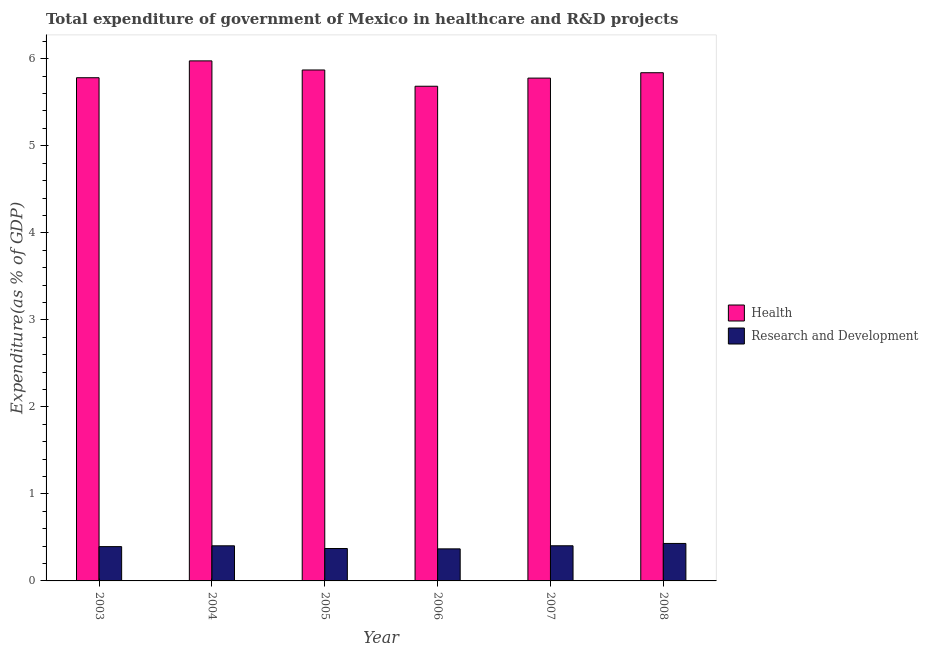How many different coloured bars are there?
Ensure brevity in your answer.  2. How many groups of bars are there?
Give a very brief answer. 6. Are the number of bars per tick equal to the number of legend labels?
Offer a very short reply. Yes. How many bars are there on the 5th tick from the left?
Provide a short and direct response. 2. How many bars are there on the 2nd tick from the right?
Provide a short and direct response. 2. What is the label of the 5th group of bars from the left?
Provide a short and direct response. 2007. In how many cases, is the number of bars for a given year not equal to the number of legend labels?
Offer a terse response. 0. What is the expenditure in healthcare in 2006?
Your answer should be compact. 5.68. Across all years, what is the maximum expenditure in r&d?
Keep it short and to the point. 0.43. Across all years, what is the minimum expenditure in healthcare?
Your answer should be very brief. 5.68. In which year was the expenditure in healthcare maximum?
Your answer should be compact. 2004. In which year was the expenditure in healthcare minimum?
Offer a terse response. 2006. What is the total expenditure in healthcare in the graph?
Offer a very short reply. 34.93. What is the difference between the expenditure in healthcare in 2004 and that in 2005?
Your answer should be very brief. 0.1. What is the difference between the expenditure in r&d in 2006 and the expenditure in healthcare in 2003?
Your answer should be very brief. -0.03. What is the average expenditure in r&d per year?
Your response must be concise. 0.4. In the year 2005, what is the difference between the expenditure in healthcare and expenditure in r&d?
Give a very brief answer. 0. In how many years, is the expenditure in r&d greater than 3.2 %?
Ensure brevity in your answer.  0. What is the ratio of the expenditure in r&d in 2003 to that in 2008?
Your answer should be compact. 0.92. What is the difference between the highest and the second highest expenditure in healthcare?
Ensure brevity in your answer.  0.1. What is the difference between the highest and the lowest expenditure in healthcare?
Your answer should be compact. 0.29. In how many years, is the expenditure in r&d greater than the average expenditure in r&d taken over all years?
Make the answer very short. 3. Is the sum of the expenditure in healthcare in 2007 and 2008 greater than the maximum expenditure in r&d across all years?
Offer a very short reply. Yes. What does the 2nd bar from the left in 2007 represents?
Your answer should be compact. Research and Development. What does the 1st bar from the right in 2007 represents?
Provide a short and direct response. Research and Development. How many bars are there?
Your response must be concise. 12. Are all the bars in the graph horizontal?
Offer a terse response. No. How many years are there in the graph?
Keep it short and to the point. 6. Does the graph contain any zero values?
Offer a very short reply. No. Where does the legend appear in the graph?
Your answer should be compact. Center right. How many legend labels are there?
Offer a terse response. 2. What is the title of the graph?
Your answer should be very brief. Total expenditure of government of Mexico in healthcare and R&D projects. Does "GDP per capita" appear as one of the legend labels in the graph?
Offer a terse response. No. What is the label or title of the X-axis?
Keep it short and to the point. Year. What is the label or title of the Y-axis?
Offer a very short reply. Expenditure(as % of GDP). What is the Expenditure(as % of GDP) in Health in 2003?
Your response must be concise. 5.78. What is the Expenditure(as % of GDP) in Research and Development in 2003?
Your answer should be compact. 0.39. What is the Expenditure(as % of GDP) of Health in 2004?
Your answer should be compact. 5.98. What is the Expenditure(as % of GDP) in Research and Development in 2004?
Give a very brief answer. 0.4. What is the Expenditure(as % of GDP) in Health in 2005?
Your response must be concise. 5.87. What is the Expenditure(as % of GDP) in Research and Development in 2005?
Provide a succinct answer. 0.37. What is the Expenditure(as % of GDP) in Health in 2006?
Provide a succinct answer. 5.68. What is the Expenditure(as % of GDP) of Research and Development in 2006?
Give a very brief answer. 0.37. What is the Expenditure(as % of GDP) of Health in 2007?
Your answer should be very brief. 5.78. What is the Expenditure(as % of GDP) of Research and Development in 2007?
Offer a very short reply. 0.4. What is the Expenditure(as % of GDP) in Health in 2008?
Provide a succinct answer. 5.84. What is the Expenditure(as % of GDP) of Research and Development in 2008?
Provide a succinct answer. 0.43. Across all years, what is the maximum Expenditure(as % of GDP) in Health?
Your answer should be compact. 5.98. Across all years, what is the maximum Expenditure(as % of GDP) in Research and Development?
Provide a succinct answer. 0.43. Across all years, what is the minimum Expenditure(as % of GDP) in Health?
Your answer should be very brief. 5.68. Across all years, what is the minimum Expenditure(as % of GDP) in Research and Development?
Ensure brevity in your answer.  0.37. What is the total Expenditure(as % of GDP) of Health in the graph?
Offer a terse response. 34.93. What is the total Expenditure(as % of GDP) of Research and Development in the graph?
Your answer should be very brief. 2.37. What is the difference between the Expenditure(as % of GDP) in Health in 2003 and that in 2004?
Your response must be concise. -0.19. What is the difference between the Expenditure(as % of GDP) in Research and Development in 2003 and that in 2004?
Offer a very short reply. -0.01. What is the difference between the Expenditure(as % of GDP) of Health in 2003 and that in 2005?
Provide a succinct answer. -0.09. What is the difference between the Expenditure(as % of GDP) of Research and Development in 2003 and that in 2005?
Make the answer very short. 0.02. What is the difference between the Expenditure(as % of GDP) in Health in 2003 and that in 2006?
Ensure brevity in your answer.  0.1. What is the difference between the Expenditure(as % of GDP) of Research and Development in 2003 and that in 2006?
Make the answer very short. 0.03. What is the difference between the Expenditure(as % of GDP) of Health in 2003 and that in 2007?
Your answer should be compact. 0. What is the difference between the Expenditure(as % of GDP) of Research and Development in 2003 and that in 2007?
Ensure brevity in your answer.  -0.01. What is the difference between the Expenditure(as % of GDP) in Health in 2003 and that in 2008?
Offer a very short reply. -0.06. What is the difference between the Expenditure(as % of GDP) of Research and Development in 2003 and that in 2008?
Provide a succinct answer. -0.04. What is the difference between the Expenditure(as % of GDP) of Health in 2004 and that in 2005?
Your answer should be very brief. 0.1. What is the difference between the Expenditure(as % of GDP) in Research and Development in 2004 and that in 2005?
Your answer should be very brief. 0.03. What is the difference between the Expenditure(as % of GDP) in Health in 2004 and that in 2006?
Keep it short and to the point. 0.29. What is the difference between the Expenditure(as % of GDP) in Research and Development in 2004 and that in 2006?
Your answer should be compact. 0.04. What is the difference between the Expenditure(as % of GDP) in Health in 2004 and that in 2007?
Make the answer very short. 0.2. What is the difference between the Expenditure(as % of GDP) in Research and Development in 2004 and that in 2007?
Offer a terse response. -0. What is the difference between the Expenditure(as % of GDP) of Health in 2004 and that in 2008?
Provide a succinct answer. 0.14. What is the difference between the Expenditure(as % of GDP) of Research and Development in 2004 and that in 2008?
Offer a terse response. -0.03. What is the difference between the Expenditure(as % of GDP) of Health in 2005 and that in 2006?
Your response must be concise. 0.19. What is the difference between the Expenditure(as % of GDP) in Research and Development in 2005 and that in 2006?
Your answer should be very brief. 0. What is the difference between the Expenditure(as % of GDP) of Health in 2005 and that in 2007?
Your answer should be very brief. 0.09. What is the difference between the Expenditure(as % of GDP) in Research and Development in 2005 and that in 2007?
Offer a very short reply. -0.03. What is the difference between the Expenditure(as % of GDP) in Health in 2005 and that in 2008?
Offer a very short reply. 0.03. What is the difference between the Expenditure(as % of GDP) in Research and Development in 2005 and that in 2008?
Offer a very short reply. -0.06. What is the difference between the Expenditure(as % of GDP) in Health in 2006 and that in 2007?
Keep it short and to the point. -0.09. What is the difference between the Expenditure(as % of GDP) of Research and Development in 2006 and that in 2007?
Your answer should be very brief. -0.04. What is the difference between the Expenditure(as % of GDP) in Health in 2006 and that in 2008?
Your answer should be compact. -0.16. What is the difference between the Expenditure(as % of GDP) in Research and Development in 2006 and that in 2008?
Offer a very short reply. -0.06. What is the difference between the Expenditure(as % of GDP) in Health in 2007 and that in 2008?
Keep it short and to the point. -0.06. What is the difference between the Expenditure(as % of GDP) in Research and Development in 2007 and that in 2008?
Offer a very short reply. -0.03. What is the difference between the Expenditure(as % of GDP) of Health in 2003 and the Expenditure(as % of GDP) of Research and Development in 2004?
Your answer should be very brief. 5.38. What is the difference between the Expenditure(as % of GDP) of Health in 2003 and the Expenditure(as % of GDP) of Research and Development in 2005?
Give a very brief answer. 5.41. What is the difference between the Expenditure(as % of GDP) in Health in 2003 and the Expenditure(as % of GDP) in Research and Development in 2006?
Your response must be concise. 5.41. What is the difference between the Expenditure(as % of GDP) of Health in 2003 and the Expenditure(as % of GDP) of Research and Development in 2007?
Your response must be concise. 5.38. What is the difference between the Expenditure(as % of GDP) of Health in 2003 and the Expenditure(as % of GDP) of Research and Development in 2008?
Provide a short and direct response. 5.35. What is the difference between the Expenditure(as % of GDP) in Health in 2004 and the Expenditure(as % of GDP) in Research and Development in 2005?
Your answer should be compact. 5.6. What is the difference between the Expenditure(as % of GDP) of Health in 2004 and the Expenditure(as % of GDP) of Research and Development in 2006?
Provide a short and direct response. 5.61. What is the difference between the Expenditure(as % of GDP) in Health in 2004 and the Expenditure(as % of GDP) in Research and Development in 2007?
Provide a succinct answer. 5.57. What is the difference between the Expenditure(as % of GDP) in Health in 2004 and the Expenditure(as % of GDP) in Research and Development in 2008?
Provide a succinct answer. 5.55. What is the difference between the Expenditure(as % of GDP) in Health in 2005 and the Expenditure(as % of GDP) in Research and Development in 2006?
Provide a short and direct response. 5.5. What is the difference between the Expenditure(as % of GDP) in Health in 2005 and the Expenditure(as % of GDP) in Research and Development in 2007?
Provide a short and direct response. 5.47. What is the difference between the Expenditure(as % of GDP) of Health in 2005 and the Expenditure(as % of GDP) of Research and Development in 2008?
Ensure brevity in your answer.  5.44. What is the difference between the Expenditure(as % of GDP) in Health in 2006 and the Expenditure(as % of GDP) in Research and Development in 2007?
Provide a short and direct response. 5.28. What is the difference between the Expenditure(as % of GDP) in Health in 2006 and the Expenditure(as % of GDP) in Research and Development in 2008?
Your answer should be compact. 5.25. What is the difference between the Expenditure(as % of GDP) of Health in 2007 and the Expenditure(as % of GDP) of Research and Development in 2008?
Ensure brevity in your answer.  5.35. What is the average Expenditure(as % of GDP) of Health per year?
Give a very brief answer. 5.82. What is the average Expenditure(as % of GDP) in Research and Development per year?
Your answer should be very brief. 0.4. In the year 2003, what is the difference between the Expenditure(as % of GDP) in Health and Expenditure(as % of GDP) in Research and Development?
Your answer should be compact. 5.39. In the year 2004, what is the difference between the Expenditure(as % of GDP) in Health and Expenditure(as % of GDP) in Research and Development?
Your answer should be compact. 5.57. In the year 2005, what is the difference between the Expenditure(as % of GDP) in Health and Expenditure(as % of GDP) in Research and Development?
Provide a succinct answer. 5.5. In the year 2006, what is the difference between the Expenditure(as % of GDP) of Health and Expenditure(as % of GDP) of Research and Development?
Make the answer very short. 5.32. In the year 2007, what is the difference between the Expenditure(as % of GDP) of Health and Expenditure(as % of GDP) of Research and Development?
Your response must be concise. 5.37. In the year 2008, what is the difference between the Expenditure(as % of GDP) of Health and Expenditure(as % of GDP) of Research and Development?
Your answer should be compact. 5.41. What is the ratio of the Expenditure(as % of GDP) in Health in 2003 to that in 2004?
Provide a short and direct response. 0.97. What is the ratio of the Expenditure(as % of GDP) of Research and Development in 2003 to that in 2004?
Provide a short and direct response. 0.98. What is the ratio of the Expenditure(as % of GDP) of Research and Development in 2003 to that in 2005?
Your answer should be very brief. 1.06. What is the ratio of the Expenditure(as % of GDP) of Health in 2003 to that in 2006?
Your response must be concise. 1.02. What is the ratio of the Expenditure(as % of GDP) in Research and Development in 2003 to that in 2006?
Your answer should be very brief. 1.07. What is the ratio of the Expenditure(as % of GDP) of Research and Development in 2003 to that in 2007?
Provide a short and direct response. 0.98. What is the ratio of the Expenditure(as % of GDP) of Health in 2003 to that in 2008?
Your response must be concise. 0.99. What is the ratio of the Expenditure(as % of GDP) of Research and Development in 2003 to that in 2008?
Keep it short and to the point. 0.92. What is the ratio of the Expenditure(as % of GDP) in Health in 2004 to that in 2005?
Offer a very short reply. 1.02. What is the ratio of the Expenditure(as % of GDP) in Research and Development in 2004 to that in 2005?
Make the answer very short. 1.08. What is the ratio of the Expenditure(as % of GDP) of Health in 2004 to that in 2006?
Keep it short and to the point. 1.05. What is the ratio of the Expenditure(as % of GDP) of Research and Development in 2004 to that in 2006?
Your answer should be compact. 1.1. What is the ratio of the Expenditure(as % of GDP) in Health in 2004 to that in 2007?
Offer a terse response. 1.03. What is the ratio of the Expenditure(as % of GDP) in Health in 2004 to that in 2008?
Your response must be concise. 1.02. What is the ratio of the Expenditure(as % of GDP) in Research and Development in 2004 to that in 2008?
Make the answer very short. 0.94. What is the ratio of the Expenditure(as % of GDP) of Health in 2005 to that in 2006?
Your answer should be compact. 1.03. What is the ratio of the Expenditure(as % of GDP) in Research and Development in 2005 to that in 2006?
Give a very brief answer. 1.01. What is the ratio of the Expenditure(as % of GDP) in Health in 2005 to that in 2007?
Provide a succinct answer. 1.02. What is the ratio of the Expenditure(as % of GDP) in Research and Development in 2005 to that in 2007?
Offer a very short reply. 0.92. What is the ratio of the Expenditure(as % of GDP) in Health in 2005 to that in 2008?
Your response must be concise. 1.01. What is the ratio of the Expenditure(as % of GDP) in Research and Development in 2005 to that in 2008?
Give a very brief answer. 0.86. What is the ratio of the Expenditure(as % of GDP) in Health in 2006 to that in 2007?
Ensure brevity in your answer.  0.98. What is the ratio of the Expenditure(as % of GDP) in Research and Development in 2006 to that in 2007?
Ensure brevity in your answer.  0.91. What is the ratio of the Expenditure(as % of GDP) of Health in 2006 to that in 2008?
Your response must be concise. 0.97. What is the ratio of the Expenditure(as % of GDP) in Research and Development in 2006 to that in 2008?
Offer a terse response. 0.86. What is the ratio of the Expenditure(as % of GDP) in Health in 2007 to that in 2008?
Provide a succinct answer. 0.99. What is the ratio of the Expenditure(as % of GDP) in Research and Development in 2007 to that in 2008?
Your answer should be very brief. 0.94. What is the difference between the highest and the second highest Expenditure(as % of GDP) in Health?
Make the answer very short. 0.1. What is the difference between the highest and the second highest Expenditure(as % of GDP) of Research and Development?
Provide a succinct answer. 0.03. What is the difference between the highest and the lowest Expenditure(as % of GDP) of Health?
Your answer should be compact. 0.29. What is the difference between the highest and the lowest Expenditure(as % of GDP) in Research and Development?
Ensure brevity in your answer.  0.06. 